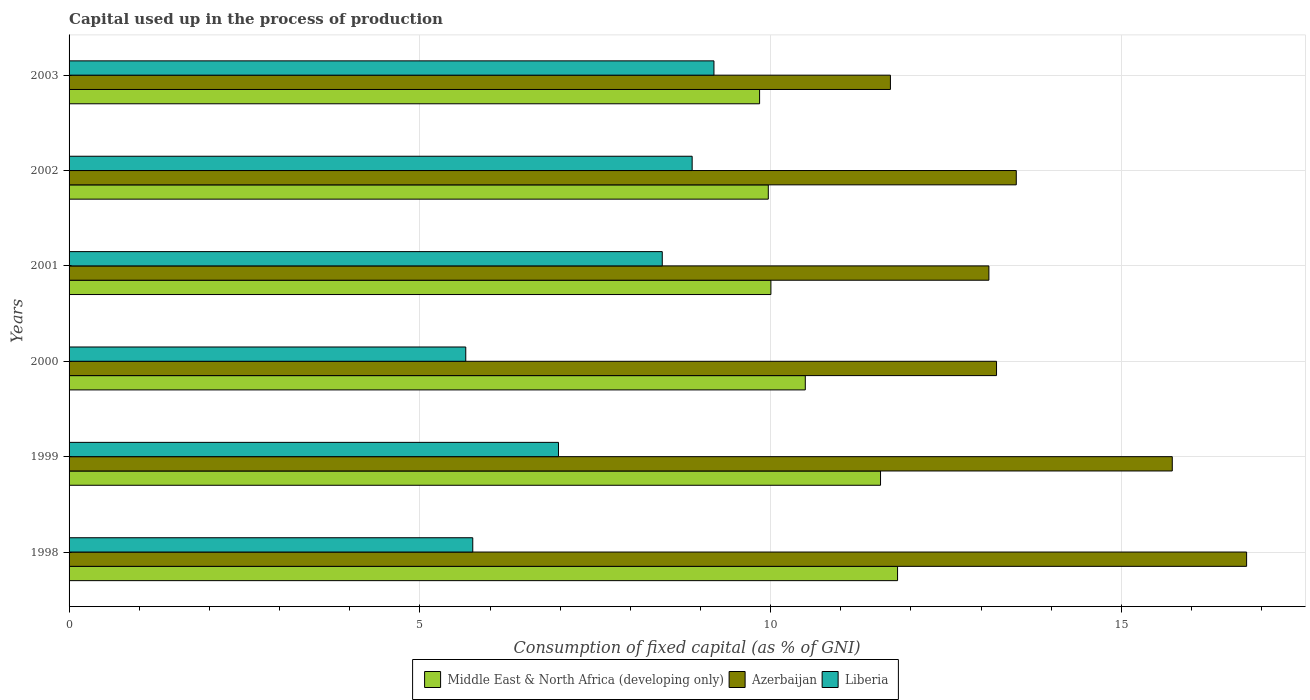How many different coloured bars are there?
Offer a very short reply. 3. Are the number of bars per tick equal to the number of legend labels?
Give a very brief answer. Yes. Are the number of bars on each tick of the Y-axis equal?
Offer a very short reply. Yes. How many bars are there on the 1st tick from the top?
Keep it short and to the point. 3. How many bars are there on the 3rd tick from the bottom?
Provide a succinct answer. 3. What is the label of the 6th group of bars from the top?
Provide a succinct answer. 1998. What is the capital used up in the process of production in Middle East & North Africa (developing only) in 1999?
Provide a short and direct response. 11.57. Across all years, what is the maximum capital used up in the process of production in Liberia?
Your response must be concise. 9.19. Across all years, what is the minimum capital used up in the process of production in Azerbaijan?
Provide a succinct answer. 11.71. In which year was the capital used up in the process of production in Azerbaijan maximum?
Offer a very short reply. 1998. In which year was the capital used up in the process of production in Liberia minimum?
Offer a very short reply. 2000. What is the total capital used up in the process of production in Middle East & North Africa (developing only) in the graph?
Ensure brevity in your answer.  63.68. What is the difference between the capital used up in the process of production in Azerbaijan in 1999 and that in 2000?
Provide a succinct answer. 2.51. What is the difference between the capital used up in the process of production in Azerbaijan in 2003 and the capital used up in the process of production in Liberia in 2002?
Give a very brief answer. 2.83. What is the average capital used up in the process of production in Azerbaijan per year?
Keep it short and to the point. 14.01. In the year 1998, what is the difference between the capital used up in the process of production in Azerbaijan and capital used up in the process of production in Middle East & North Africa (developing only)?
Make the answer very short. 4.98. What is the ratio of the capital used up in the process of production in Middle East & North Africa (developing only) in 2001 to that in 2002?
Offer a very short reply. 1. Is the capital used up in the process of production in Middle East & North Africa (developing only) in 2001 less than that in 2003?
Your answer should be compact. No. Is the difference between the capital used up in the process of production in Azerbaijan in 1999 and 2000 greater than the difference between the capital used up in the process of production in Middle East & North Africa (developing only) in 1999 and 2000?
Offer a terse response. Yes. What is the difference between the highest and the second highest capital used up in the process of production in Middle East & North Africa (developing only)?
Make the answer very short. 0.24. What is the difference between the highest and the lowest capital used up in the process of production in Azerbaijan?
Provide a short and direct response. 5.08. In how many years, is the capital used up in the process of production in Liberia greater than the average capital used up in the process of production in Liberia taken over all years?
Ensure brevity in your answer.  3. Is the sum of the capital used up in the process of production in Azerbaijan in 1999 and 2002 greater than the maximum capital used up in the process of production in Liberia across all years?
Give a very brief answer. Yes. What does the 3rd bar from the top in 2002 represents?
Keep it short and to the point. Middle East & North Africa (developing only). What does the 2nd bar from the bottom in 1998 represents?
Make the answer very short. Azerbaijan. How many bars are there?
Ensure brevity in your answer.  18. Are all the bars in the graph horizontal?
Offer a terse response. Yes. Are the values on the major ticks of X-axis written in scientific E-notation?
Provide a succinct answer. No. Does the graph contain any zero values?
Make the answer very short. No. Does the graph contain grids?
Offer a terse response. Yes. How many legend labels are there?
Your answer should be very brief. 3. What is the title of the graph?
Your answer should be compact. Capital used up in the process of production. What is the label or title of the X-axis?
Make the answer very short. Consumption of fixed capital (as % of GNI). What is the Consumption of fixed capital (as % of GNI) in Middle East & North Africa (developing only) in 1998?
Ensure brevity in your answer.  11.81. What is the Consumption of fixed capital (as % of GNI) of Azerbaijan in 1998?
Offer a terse response. 16.78. What is the Consumption of fixed capital (as % of GNI) of Liberia in 1998?
Keep it short and to the point. 5.75. What is the Consumption of fixed capital (as % of GNI) in Middle East & North Africa (developing only) in 1999?
Provide a succinct answer. 11.57. What is the Consumption of fixed capital (as % of GNI) of Azerbaijan in 1999?
Provide a succinct answer. 15.73. What is the Consumption of fixed capital (as % of GNI) in Liberia in 1999?
Provide a succinct answer. 6.98. What is the Consumption of fixed capital (as % of GNI) in Middle East & North Africa (developing only) in 2000?
Provide a succinct answer. 10.49. What is the Consumption of fixed capital (as % of GNI) of Azerbaijan in 2000?
Keep it short and to the point. 13.22. What is the Consumption of fixed capital (as % of GNI) of Liberia in 2000?
Offer a very short reply. 5.65. What is the Consumption of fixed capital (as % of GNI) of Middle East & North Africa (developing only) in 2001?
Keep it short and to the point. 10. What is the Consumption of fixed capital (as % of GNI) of Azerbaijan in 2001?
Keep it short and to the point. 13.11. What is the Consumption of fixed capital (as % of GNI) of Liberia in 2001?
Provide a succinct answer. 8.46. What is the Consumption of fixed capital (as % of GNI) of Middle East & North Africa (developing only) in 2002?
Make the answer very short. 9.97. What is the Consumption of fixed capital (as % of GNI) of Azerbaijan in 2002?
Your response must be concise. 13.5. What is the Consumption of fixed capital (as % of GNI) in Liberia in 2002?
Your response must be concise. 8.88. What is the Consumption of fixed capital (as % of GNI) in Middle East & North Africa (developing only) in 2003?
Your answer should be compact. 9.84. What is the Consumption of fixed capital (as % of GNI) of Azerbaijan in 2003?
Keep it short and to the point. 11.71. What is the Consumption of fixed capital (as % of GNI) in Liberia in 2003?
Ensure brevity in your answer.  9.19. Across all years, what is the maximum Consumption of fixed capital (as % of GNI) in Middle East & North Africa (developing only)?
Offer a terse response. 11.81. Across all years, what is the maximum Consumption of fixed capital (as % of GNI) of Azerbaijan?
Offer a very short reply. 16.78. Across all years, what is the maximum Consumption of fixed capital (as % of GNI) in Liberia?
Provide a short and direct response. 9.19. Across all years, what is the minimum Consumption of fixed capital (as % of GNI) of Middle East & North Africa (developing only)?
Ensure brevity in your answer.  9.84. Across all years, what is the minimum Consumption of fixed capital (as % of GNI) of Azerbaijan?
Keep it short and to the point. 11.71. Across all years, what is the minimum Consumption of fixed capital (as % of GNI) in Liberia?
Your answer should be very brief. 5.65. What is the total Consumption of fixed capital (as % of GNI) of Middle East & North Africa (developing only) in the graph?
Offer a terse response. 63.68. What is the total Consumption of fixed capital (as % of GNI) of Azerbaijan in the graph?
Offer a very short reply. 84.05. What is the total Consumption of fixed capital (as % of GNI) in Liberia in the graph?
Provide a succinct answer. 44.91. What is the difference between the Consumption of fixed capital (as % of GNI) of Middle East & North Africa (developing only) in 1998 and that in 1999?
Ensure brevity in your answer.  0.24. What is the difference between the Consumption of fixed capital (as % of GNI) in Azerbaijan in 1998 and that in 1999?
Your answer should be compact. 1.06. What is the difference between the Consumption of fixed capital (as % of GNI) in Liberia in 1998 and that in 1999?
Make the answer very short. -1.22. What is the difference between the Consumption of fixed capital (as % of GNI) in Middle East & North Africa (developing only) in 1998 and that in 2000?
Your response must be concise. 1.31. What is the difference between the Consumption of fixed capital (as % of GNI) in Azerbaijan in 1998 and that in 2000?
Make the answer very short. 3.56. What is the difference between the Consumption of fixed capital (as % of GNI) of Liberia in 1998 and that in 2000?
Your answer should be very brief. 0.1. What is the difference between the Consumption of fixed capital (as % of GNI) of Middle East & North Africa (developing only) in 1998 and that in 2001?
Offer a terse response. 1.81. What is the difference between the Consumption of fixed capital (as % of GNI) in Azerbaijan in 1998 and that in 2001?
Give a very brief answer. 3.67. What is the difference between the Consumption of fixed capital (as % of GNI) of Liberia in 1998 and that in 2001?
Your answer should be compact. -2.7. What is the difference between the Consumption of fixed capital (as % of GNI) of Middle East & North Africa (developing only) in 1998 and that in 2002?
Offer a very short reply. 1.84. What is the difference between the Consumption of fixed capital (as % of GNI) of Azerbaijan in 1998 and that in 2002?
Offer a terse response. 3.28. What is the difference between the Consumption of fixed capital (as % of GNI) in Liberia in 1998 and that in 2002?
Your answer should be compact. -3.13. What is the difference between the Consumption of fixed capital (as % of GNI) of Middle East & North Africa (developing only) in 1998 and that in 2003?
Your answer should be very brief. 1.97. What is the difference between the Consumption of fixed capital (as % of GNI) of Azerbaijan in 1998 and that in 2003?
Give a very brief answer. 5.08. What is the difference between the Consumption of fixed capital (as % of GNI) in Liberia in 1998 and that in 2003?
Make the answer very short. -3.44. What is the difference between the Consumption of fixed capital (as % of GNI) of Middle East & North Africa (developing only) in 1999 and that in 2000?
Offer a very short reply. 1.07. What is the difference between the Consumption of fixed capital (as % of GNI) in Azerbaijan in 1999 and that in 2000?
Keep it short and to the point. 2.51. What is the difference between the Consumption of fixed capital (as % of GNI) of Liberia in 1999 and that in 2000?
Your answer should be compact. 1.32. What is the difference between the Consumption of fixed capital (as % of GNI) in Middle East & North Africa (developing only) in 1999 and that in 2001?
Your answer should be compact. 1.56. What is the difference between the Consumption of fixed capital (as % of GNI) in Azerbaijan in 1999 and that in 2001?
Keep it short and to the point. 2.61. What is the difference between the Consumption of fixed capital (as % of GNI) of Liberia in 1999 and that in 2001?
Ensure brevity in your answer.  -1.48. What is the difference between the Consumption of fixed capital (as % of GNI) of Middle East & North Africa (developing only) in 1999 and that in 2002?
Provide a short and direct response. 1.6. What is the difference between the Consumption of fixed capital (as % of GNI) of Azerbaijan in 1999 and that in 2002?
Your answer should be compact. 2.22. What is the difference between the Consumption of fixed capital (as % of GNI) in Liberia in 1999 and that in 2002?
Provide a succinct answer. -1.91. What is the difference between the Consumption of fixed capital (as % of GNI) of Middle East & North Africa (developing only) in 1999 and that in 2003?
Keep it short and to the point. 1.72. What is the difference between the Consumption of fixed capital (as % of GNI) of Azerbaijan in 1999 and that in 2003?
Your answer should be very brief. 4.02. What is the difference between the Consumption of fixed capital (as % of GNI) of Liberia in 1999 and that in 2003?
Provide a short and direct response. -2.22. What is the difference between the Consumption of fixed capital (as % of GNI) in Middle East & North Africa (developing only) in 2000 and that in 2001?
Offer a terse response. 0.49. What is the difference between the Consumption of fixed capital (as % of GNI) in Azerbaijan in 2000 and that in 2001?
Your answer should be compact. 0.11. What is the difference between the Consumption of fixed capital (as % of GNI) in Liberia in 2000 and that in 2001?
Ensure brevity in your answer.  -2.8. What is the difference between the Consumption of fixed capital (as % of GNI) of Middle East & North Africa (developing only) in 2000 and that in 2002?
Make the answer very short. 0.53. What is the difference between the Consumption of fixed capital (as % of GNI) of Azerbaijan in 2000 and that in 2002?
Provide a succinct answer. -0.28. What is the difference between the Consumption of fixed capital (as % of GNI) in Liberia in 2000 and that in 2002?
Ensure brevity in your answer.  -3.23. What is the difference between the Consumption of fixed capital (as % of GNI) of Middle East & North Africa (developing only) in 2000 and that in 2003?
Provide a short and direct response. 0.65. What is the difference between the Consumption of fixed capital (as % of GNI) in Azerbaijan in 2000 and that in 2003?
Offer a very short reply. 1.51. What is the difference between the Consumption of fixed capital (as % of GNI) of Liberia in 2000 and that in 2003?
Keep it short and to the point. -3.54. What is the difference between the Consumption of fixed capital (as % of GNI) of Middle East & North Africa (developing only) in 2001 and that in 2002?
Offer a very short reply. 0.04. What is the difference between the Consumption of fixed capital (as % of GNI) in Azerbaijan in 2001 and that in 2002?
Your answer should be compact. -0.39. What is the difference between the Consumption of fixed capital (as % of GNI) in Liberia in 2001 and that in 2002?
Your answer should be very brief. -0.43. What is the difference between the Consumption of fixed capital (as % of GNI) of Middle East & North Africa (developing only) in 2001 and that in 2003?
Offer a very short reply. 0.16. What is the difference between the Consumption of fixed capital (as % of GNI) in Azerbaijan in 2001 and that in 2003?
Your response must be concise. 1.4. What is the difference between the Consumption of fixed capital (as % of GNI) in Liberia in 2001 and that in 2003?
Give a very brief answer. -0.74. What is the difference between the Consumption of fixed capital (as % of GNI) of Middle East & North Africa (developing only) in 2002 and that in 2003?
Provide a succinct answer. 0.12. What is the difference between the Consumption of fixed capital (as % of GNI) of Azerbaijan in 2002 and that in 2003?
Your answer should be compact. 1.79. What is the difference between the Consumption of fixed capital (as % of GNI) of Liberia in 2002 and that in 2003?
Your answer should be compact. -0.31. What is the difference between the Consumption of fixed capital (as % of GNI) of Middle East & North Africa (developing only) in 1998 and the Consumption of fixed capital (as % of GNI) of Azerbaijan in 1999?
Provide a short and direct response. -3.92. What is the difference between the Consumption of fixed capital (as % of GNI) of Middle East & North Africa (developing only) in 1998 and the Consumption of fixed capital (as % of GNI) of Liberia in 1999?
Offer a terse response. 4.83. What is the difference between the Consumption of fixed capital (as % of GNI) of Azerbaijan in 1998 and the Consumption of fixed capital (as % of GNI) of Liberia in 1999?
Your answer should be very brief. 9.81. What is the difference between the Consumption of fixed capital (as % of GNI) in Middle East & North Africa (developing only) in 1998 and the Consumption of fixed capital (as % of GNI) in Azerbaijan in 2000?
Your response must be concise. -1.41. What is the difference between the Consumption of fixed capital (as % of GNI) in Middle East & North Africa (developing only) in 1998 and the Consumption of fixed capital (as % of GNI) in Liberia in 2000?
Your response must be concise. 6.15. What is the difference between the Consumption of fixed capital (as % of GNI) of Azerbaijan in 1998 and the Consumption of fixed capital (as % of GNI) of Liberia in 2000?
Your answer should be compact. 11.13. What is the difference between the Consumption of fixed capital (as % of GNI) in Middle East & North Africa (developing only) in 1998 and the Consumption of fixed capital (as % of GNI) in Azerbaijan in 2001?
Offer a very short reply. -1.3. What is the difference between the Consumption of fixed capital (as % of GNI) of Middle East & North Africa (developing only) in 1998 and the Consumption of fixed capital (as % of GNI) of Liberia in 2001?
Your answer should be compact. 3.35. What is the difference between the Consumption of fixed capital (as % of GNI) of Azerbaijan in 1998 and the Consumption of fixed capital (as % of GNI) of Liberia in 2001?
Your response must be concise. 8.33. What is the difference between the Consumption of fixed capital (as % of GNI) in Middle East & North Africa (developing only) in 1998 and the Consumption of fixed capital (as % of GNI) in Azerbaijan in 2002?
Your response must be concise. -1.69. What is the difference between the Consumption of fixed capital (as % of GNI) in Middle East & North Africa (developing only) in 1998 and the Consumption of fixed capital (as % of GNI) in Liberia in 2002?
Give a very brief answer. 2.93. What is the difference between the Consumption of fixed capital (as % of GNI) in Azerbaijan in 1998 and the Consumption of fixed capital (as % of GNI) in Liberia in 2002?
Your answer should be very brief. 7.9. What is the difference between the Consumption of fixed capital (as % of GNI) in Middle East & North Africa (developing only) in 1998 and the Consumption of fixed capital (as % of GNI) in Azerbaijan in 2003?
Provide a short and direct response. 0.1. What is the difference between the Consumption of fixed capital (as % of GNI) of Middle East & North Africa (developing only) in 1998 and the Consumption of fixed capital (as % of GNI) of Liberia in 2003?
Give a very brief answer. 2.62. What is the difference between the Consumption of fixed capital (as % of GNI) in Azerbaijan in 1998 and the Consumption of fixed capital (as % of GNI) in Liberia in 2003?
Your answer should be compact. 7.59. What is the difference between the Consumption of fixed capital (as % of GNI) in Middle East & North Africa (developing only) in 1999 and the Consumption of fixed capital (as % of GNI) in Azerbaijan in 2000?
Keep it short and to the point. -1.65. What is the difference between the Consumption of fixed capital (as % of GNI) in Middle East & North Africa (developing only) in 1999 and the Consumption of fixed capital (as % of GNI) in Liberia in 2000?
Give a very brief answer. 5.91. What is the difference between the Consumption of fixed capital (as % of GNI) in Azerbaijan in 1999 and the Consumption of fixed capital (as % of GNI) in Liberia in 2000?
Provide a succinct answer. 10.07. What is the difference between the Consumption of fixed capital (as % of GNI) in Middle East & North Africa (developing only) in 1999 and the Consumption of fixed capital (as % of GNI) in Azerbaijan in 2001?
Make the answer very short. -1.54. What is the difference between the Consumption of fixed capital (as % of GNI) of Middle East & North Africa (developing only) in 1999 and the Consumption of fixed capital (as % of GNI) of Liberia in 2001?
Your answer should be very brief. 3.11. What is the difference between the Consumption of fixed capital (as % of GNI) of Azerbaijan in 1999 and the Consumption of fixed capital (as % of GNI) of Liberia in 2001?
Make the answer very short. 7.27. What is the difference between the Consumption of fixed capital (as % of GNI) in Middle East & North Africa (developing only) in 1999 and the Consumption of fixed capital (as % of GNI) in Azerbaijan in 2002?
Your answer should be very brief. -1.94. What is the difference between the Consumption of fixed capital (as % of GNI) in Middle East & North Africa (developing only) in 1999 and the Consumption of fixed capital (as % of GNI) in Liberia in 2002?
Your response must be concise. 2.69. What is the difference between the Consumption of fixed capital (as % of GNI) in Azerbaijan in 1999 and the Consumption of fixed capital (as % of GNI) in Liberia in 2002?
Offer a terse response. 6.84. What is the difference between the Consumption of fixed capital (as % of GNI) in Middle East & North Africa (developing only) in 1999 and the Consumption of fixed capital (as % of GNI) in Azerbaijan in 2003?
Ensure brevity in your answer.  -0.14. What is the difference between the Consumption of fixed capital (as % of GNI) of Middle East & North Africa (developing only) in 1999 and the Consumption of fixed capital (as % of GNI) of Liberia in 2003?
Your response must be concise. 2.37. What is the difference between the Consumption of fixed capital (as % of GNI) in Azerbaijan in 1999 and the Consumption of fixed capital (as % of GNI) in Liberia in 2003?
Provide a short and direct response. 6.53. What is the difference between the Consumption of fixed capital (as % of GNI) of Middle East & North Africa (developing only) in 2000 and the Consumption of fixed capital (as % of GNI) of Azerbaijan in 2001?
Your answer should be compact. -2.62. What is the difference between the Consumption of fixed capital (as % of GNI) in Middle East & North Africa (developing only) in 2000 and the Consumption of fixed capital (as % of GNI) in Liberia in 2001?
Make the answer very short. 2.04. What is the difference between the Consumption of fixed capital (as % of GNI) of Azerbaijan in 2000 and the Consumption of fixed capital (as % of GNI) of Liberia in 2001?
Give a very brief answer. 4.76. What is the difference between the Consumption of fixed capital (as % of GNI) in Middle East & North Africa (developing only) in 2000 and the Consumption of fixed capital (as % of GNI) in Azerbaijan in 2002?
Your answer should be very brief. -3.01. What is the difference between the Consumption of fixed capital (as % of GNI) in Middle East & North Africa (developing only) in 2000 and the Consumption of fixed capital (as % of GNI) in Liberia in 2002?
Give a very brief answer. 1.61. What is the difference between the Consumption of fixed capital (as % of GNI) in Azerbaijan in 2000 and the Consumption of fixed capital (as % of GNI) in Liberia in 2002?
Your answer should be compact. 4.34. What is the difference between the Consumption of fixed capital (as % of GNI) in Middle East & North Africa (developing only) in 2000 and the Consumption of fixed capital (as % of GNI) in Azerbaijan in 2003?
Provide a succinct answer. -1.21. What is the difference between the Consumption of fixed capital (as % of GNI) of Middle East & North Africa (developing only) in 2000 and the Consumption of fixed capital (as % of GNI) of Liberia in 2003?
Give a very brief answer. 1.3. What is the difference between the Consumption of fixed capital (as % of GNI) in Azerbaijan in 2000 and the Consumption of fixed capital (as % of GNI) in Liberia in 2003?
Your answer should be very brief. 4.03. What is the difference between the Consumption of fixed capital (as % of GNI) of Middle East & North Africa (developing only) in 2001 and the Consumption of fixed capital (as % of GNI) of Azerbaijan in 2002?
Ensure brevity in your answer.  -3.5. What is the difference between the Consumption of fixed capital (as % of GNI) in Middle East & North Africa (developing only) in 2001 and the Consumption of fixed capital (as % of GNI) in Liberia in 2002?
Make the answer very short. 1.12. What is the difference between the Consumption of fixed capital (as % of GNI) of Azerbaijan in 2001 and the Consumption of fixed capital (as % of GNI) of Liberia in 2002?
Your answer should be very brief. 4.23. What is the difference between the Consumption of fixed capital (as % of GNI) in Middle East & North Africa (developing only) in 2001 and the Consumption of fixed capital (as % of GNI) in Azerbaijan in 2003?
Give a very brief answer. -1.7. What is the difference between the Consumption of fixed capital (as % of GNI) of Middle East & North Africa (developing only) in 2001 and the Consumption of fixed capital (as % of GNI) of Liberia in 2003?
Your response must be concise. 0.81. What is the difference between the Consumption of fixed capital (as % of GNI) of Azerbaijan in 2001 and the Consumption of fixed capital (as % of GNI) of Liberia in 2003?
Offer a terse response. 3.92. What is the difference between the Consumption of fixed capital (as % of GNI) of Middle East & North Africa (developing only) in 2002 and the Consumption of fixed capital (as % of GNI) of Azerbaijan in 2003?
Offer a terse response. -1.74. What is the difference between the Consumption of fixed capital (as % of GNI) of Middle East & North Africa (developing only) in 2002 and the Consumption of fixed capital (as % of GNI) of Liberia in 2003?
Provide a short and direct response. 0.77. What is the difference between the Consumption of fixed capital (as % of GNI) of Azerbaijan in 2002 and the Consumption of fixed capital (as % of GNI) of Liberia in 2003?
Keep it short and to the point. 4.31. What is the average Consumption of fixed capital (as % of GNI) in Middle East & North Africa (developing only) per year?
Offer a very short reply. 10.61. What is the average Consumption of fixed capital (as % of GNI) of Azerbaijan per year?
Your answer should be compact. 14.01. What is the average Consumption of fixed capital (as % of GNI) in Liberia per year?
Make the answer very short. 7.49. In the year 1998, what is the difference between the Consumption of fixed capital (as % of GNI) in Middle East & North Africa (developing only) and Consumption of fixed capital (as % of GNI) in Azerbaijan?
Keep it short and to the point. -4.98. In the year 1998, what is the difference between the Consumption of fixed capital (as % of GNI) in Middle East & North Africa (developing only) and Consumption of fixed capital (as % of GNI) in Liberia?
Your response must be concise. 6.05. In the year 1998, what is the difference between the Consumption of fixed capital (as % of GNI) in Azerbaijan and Consumption of fixed capital (as % of GNI) in Liberia?
Give a very brief answer. 11.03. In the year 1999, what is the difference between the Consumption of fixed capital (as % of GNI) in Middle East & North Africa (developing only) and Consumption of fixed capital (as % of GNI) in Azerbaijan?
Your answer should be very brief. -4.16. In the year 1999, what is the difference between the Consumption of fixed capital (as % of GNI) in Middle East & North Africa (developing only) and Consumption of fixed capital (as % of GNI) in Liberia?
Offer a very short reply. 4.59. In the year 1999, what is the difference between the Consumption of fixed capital (as % of GNI) of Azerbaijan and Consumption of fixed capital (as % of GNI) of Liberia?
Provide a short and direct response. 8.75. In the year 2000, what is the difference between the Consumption of fixed capital (as % of GNI) in Middle East & North Africa (developing only) and Consumption of fixed capital (as % of GNI) in Azerbaijan?
Give a very brief answer. -2.73. In the year 2000, what is the difference between the Consumption of fixed capital (as % of GNI) in Middle East & North Africa (developing only) and Consumption of fixed capital (as % of GNI) in Liberia?
Make the answer very short. 4.84. In the year 2000, what is the difference between the Consumption of fixed capital (as % of GNI) in Azerbaijan and Consumption of fixed capital (as % of GNI) in Liberia?
Offer a very short reply. 7.57. In the year 2001, what is the difference between the Consumption of fixed capital (as % of GNI) in Middle East & North Africa (developing only) and Consumption of fixed capital (as % of GNI) in Azerbaijan?
Ensure brevity in your answer.  -3.11. In the year 2001, what is the difference between the Consumption of fixed capital (as % of GNI) in Middle East & North Africa (developing only) and Consumption of fixed capital (as % of GNI) in Liberia?
Your response must be concise. 1.55. In the year 2001, what is the difference between the Consumption of fixed capital (as % of GNI) of Azerbaijan and Consumption of fixed capital (as % of GNI) of Liberia?
Ensure brevity in your answer.  4.66. In the year 2002, what is the difference between the Consumption of fixed capital (as % of GNI) of Middle East & North Africa (developing only) and Consumption of fixed capital (as % of GNI) of Azerbaijan?
Your response must be concise. -3.53. In the year 2002, what is the difference between the Consumption of fixed capital (as % of GNI) of Middle East & North Africa (developing only) and Consumption of fixed capital (as % of GNI) of Liberia?
Provide a short and direct response. 1.09. In the year 2002, what is the difference between the Consumption of fixed capital (as % of GNI) in Azerbaijan and Consumption of fixed capital (as % of GNI) in Liberia?
Provide a succinct answer. 4.62. In the year 2003, what is the difference between the Consumption of fixed capital (as % of GNI) in Middle East & North Africa (developing only) and Consumption of fixed capital (as % of GNI) in Azerbaijan?
Your answer should be compact. -1.86. In the year 2003, what is the difference between the Consumption of fixed capital (as % of GNI) of Middle East & North Africa (developing only) and Consumption of fixed capital (as % of GNI) of Liberia?
Give a very brief answer. 0.65. In the year 2003, what is the difference between the Consumption of fixed capital (as % of GNI) in Azerbaijan and Consumption of fixed capital (as % of GNI) in Liberia?
Offer a terse response. 2.52. What is the ratio of the Consumption of fixed capital (as % of GNI) of Azerbaijan in 1998 to that in 1999?
Offer a terse response. 1.07. What is the ratio of the Consumption of fixed capital (as % of GNI) of Liberia in 1998 to that in 1999?
Provide a short and direct response. 0.82. What is the ratio of the Consumption of fixed capital (as % of GNI) of Middle East & North Africa (developing only) in 1998 to that in 2000?
Your answer should be very brief. 1.13. What is the ratio of the Consumption of fixed capital (as % of GNI) in Azerbaijan in 1998 to that in 2000?
Provide a short and direct response. 1.27. What is the ratio of the Consumption of fixed capital (as % of GNI) in Liberia in 1998 to that in 2000?
Provide a short and direct response. 1.02. What is the ratio of the Consumption of fixed capital (as % of GNI) of Middle East & North Africa (developing only) in 1998 to that in 2001?
Provide a succinct answer. 1.18. What is the ratio of the Consumption of fixed capital (as % of GNI) of Azerbaijan in 1998 to that in 2001?
Keep it short and to the point. 1.28. What is the ratio of the Consumption of fixed capital (as % of GNI) of Liberia in 1998 to that in 2001?
Your answer should be very brief. 0.68. What is the ratio of the Consumption of fixed capital (as % of GNI) in Middle East & North Africa (developing only) in 1998 to that in 2002?
Offer a terse response. 1.18. What is the ratio of the Consumption of fixed capital (as % of GNI) in Azerbaijan in 1998 to that in 2002?
Make the answer very short. 1.24. What is the ratio of the Consumption of fixed capital (as % of GNI) in Liberia in 1998 to that in 2002?
Your answer should be compact. 0.65. What is the ratio of the Consumption of fixed capital (as % of GNI) in Middle East & North Africa (developing only) in 1998 to that in 2003?
Ensure brevity in your answer.  1.2. What is the ratio of the Consumption of fixed capital (as % of GNI) of Azerbaijan in 1998 to that in 2003?
Offer a terse response. 1.43. What is the ratio of the Consumption of fixed capital (as % of GNI) of Liberia in 1998 to that in 2003?
Provide a short and direct response. 0.63. What is the ratio of the Consumption of fixed capital (as % of GNI) in Middle East & North Africa (developing only) in 1999 to that in 2000?
Make the answer very short. 1.1. What is the ratio of the Consumption of fixed capital (as % of GNI) in Azerbaijan in 1999 to that in 2000?
Your answer should be compact. 1.19. What is the ratio of the Consumption of fixed capital (as % of GNI) in Liberia in 1999 to that in 2000?
Ensure brevity in your answer.  1.23. What is the ratio of the Consumption of fixed capital (as % of GNI) of Middle East & North Africa (developing only) in 1999 to that in 2001?
Provide a succinct answer. 1.16. What is the ratio of the Consumption of fixed capital (as % of GNI) in Azerbaijan in 1999 to that in 2001?
Your response must be concise. 1.2. What is the ratio of the Consumption of fixed capital (as % of GNI) of Liberia in 1999 to that in 2001?
Keep it short and to the point. 0.82. What is the ratio of the Consumption of fixed capital (as % of GNI) of Middle East & North Africa (developing only) in 1999 to that in 2002?
Ensure brevity in your answer.  1.16. What is the ratio of the Consumption of fixed capital (as % of GNI) of Azerbaijan in 1999 to that in 2002?
Offer a terse response. 1.16. What is the ratio of the Consumption of fixed capital (as % of GNI) in Liberia in 1999 to that in 2002?
Keep it short and to the point. 0.79. What is the ratio of the Consumption of fixed capital (as % of GNI) of Middle East & North Africa (developing only) in 1999 to that in 2003?
Offer a terse response. 1.18. What is the ratio of the Consumption of fixed capital (as % of GNI) in Azerbaijan in 1999 to that in 2003?
Your response must be concise. 1.34. What is the ratio of the Consumption of fixed capital (as % of GNI) in Liberia in 1999 to that in 2003?
Your response must be concise. 0.76. What is the ratio of the Consumption of fixed capital (as % of GNI) of Middle East & North Africa (developing only) in 2000 to that in 2001?
Your answer should be very brief. 1.05. What is the ratio of the Consumption of fixed capital (as % of GNI) of Azerbaijan in 2000 to that in 2001?
Your response must be concise. 1.01. What is the ratio of the Consumption of fixed capital (as % of GNI) of Liberia in 2000 to that in 2001?
Give a very brief answer. 0.67. What is the ratio of the Consumption of fixed capital (as % of GNI) of Middle East & North Africa (developing only) in 2000 to that in 2002?
Offer a terse response. 1.05. What is the ratio of the Consumption of fixed capital (as % of GNI) of Azerbaijan in 2000 to that in 2002?
Your response must be concise. 0.98. What is the ratio of the Consumption of fixed capital (as % of GNI) of Liberia in 2000 to that in 2002?
Give a very brief answer. 0.64. What is the ratio of the Consumption of fixed capital (as % of GNI) in Middle East & North Africa (developing only) in 2000 to that in 2003?
Provide a short and direct response. 1.07. What is the ratio of the Consumption of fixed capital (as % of GNI) in Azerbaijan in 2000 to that in 2003?
Keep it short and to the point. 1.13. What is the ratio of the Consumption of fixed capital (as % of GNI) of Liberia in 2000 to that in 2003?
Provide a short and direct response. 0.62. What is the ratio of the Consumption of fixed capital (as % of GNI) of Middle East & North Africa (developing only) in 2001 to that in 2002?
Keep it short and to the point. 1. What is the ratio of the Consumption of fixed capital (as % of GNI) in Azerbaijan in 2001 to that in 2002?
Provide a succinct answer. 0.97. What is the ratio of the Consumption of fixed capital (as % of GNI) of Middle East & North Africa (developing only) in 2001 to that in 2003?
Offer a terse response. 1.02. What is the ratio of the Consumption of fixed capital (as % of GNI) in Azerbaijan in 2001 to that in 2003?
Your answer should be very brief. 1.12. What is the ratio of the Consumption of fixed capital (as % of GNI) in Liberia in 2001 to that in 2003?
Provide a succinct answer. 0.92. What is the ratio of the Consumption of fixed capital (as % of GNI) in Middle East & North Africa (developing only) in 2002 to that in 2003?
Give a very brief answer. 1.01. What is the ratio of the Consumption of fixed capital (as % of GNI) of Azerbaijan in 2002 to that in 2003?
Keep it short and to the point. 1.15. What is the ratio of the Consumption of fixed capital (as % of GNI) in Liberia in 2002 to that in 2003?
Ensure brevity in your answer.  0.97. What is the difference between the highest and the second highest Consumption of fixed capital (as % of GNI) in Middle East & North Africa (developing only)?
Provide a succinct answer. 0.24. What is the difference between the highest and the second highest Consumption of fixed capital (as % of GNI) in Azerbaijan?
Provide a succinct answer. 1.06. What is the difference between the highest and the second highest Consumption of fixed capital (as % of GNI) in Liberia?
Make the answer very short. 0.31. What is the difference between the highest and the lowest Consumption of fixed capital (as % of GNI) of Middle East & North Africa (developing only)?
Your response must be concise. 1.97. What is the difference between the highest and the lowest Consumption of fixed capital (as % of GNI) in Azerbaijan?
Offer a terse response. 5.08. What is the difference between the highest and the lowest Consumption of fixed capital (as % of GNI) in Liberia?
Your answer should be compact. 3.54. 